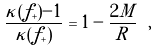<formula> <loc_0><loc_0><loc_500><loc_500>\frac { \kappa ( f _ { + } ) - 1 } { \kappa ( f _ { + } ) } = 1 - \frac { 2 M } { R } \ ,</formula> 